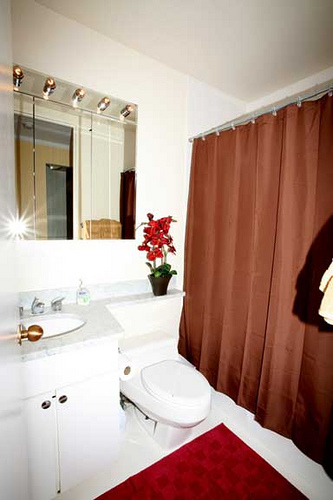<image>What kind of flower is used for the decor? I am not sure which flower is used for the decor. It could be a lilly, lily, daisy, orchid, gardenias, or carnations. What kind of flower is used for the decor? I am not sure what kind of flower is used for the decor. It can be seen 'lilly', 'lily', 'daisy', 'red', 'orchid', 'gardenias', 'orchid' or 'carnations'. 